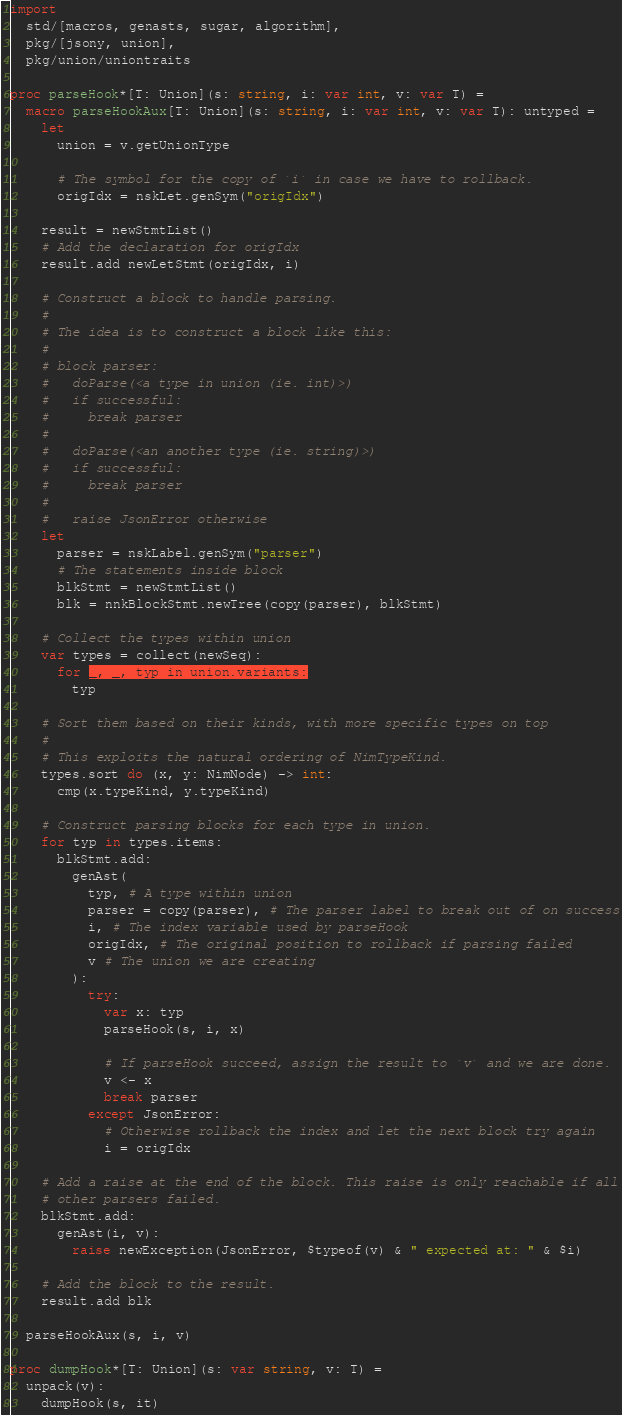Convert code to text. <code><loc_0><loc_0><loc_500><loc_500><_Nim_>import
  std/[macros, genasts, sugar, algorithm],
  pkg/[jsony, union],
  pkg/union/uniontraits

proc parseHook*[T: Union](s: string, i: var int, v: var T) =
  macro parseHookAux[T: Union](s: string, i: var int, v: var T): untyped =
    let
      union = v.getUnionType

      # The symbol for the copy of `i` in case we have to rollback.
      origIdx = nskLet.genSym("origIdx")

    result = newStmtList()
    # Add the declaration for origIdx
    result.add newLetStmt(origIdx, i)

    # Construct a block to handle parsing.
    #
    # The idea is to construct a block like this:
    #
    # block parser:
    #   doParse(<a type in union (ie. int)>)
    #   if successful:
    #     break parser
    #
    #   doParse(<an another type (ie. string)>)
    #   if successful:
    #     break parser
    #
    #   raise JsonError otherwise
    let
      parser = nskLabel.genSym("parser")
      # The statements inside block
      blkStmt = newStmtList()
      blk = nnkBlockStmt.newTree(copy(parser), blkStmt)

    # Collect the types within union
    var types = collect(newSeq):
      for _, _, typ in union.variants:
        typ

    # Sort them based on their kinds, with more specific types on top
    #
    # This exploits the natural ordering of NimTypeKind.
    types.sort do (x, y: NimNode) -> int:
      cmp(x.typeKind, y.typeKind)

    # Construct parsing blocks for each type in union.
    for typ in types.items:
      blkStmt.add:
        genAst(
          typ, # A type within union
          parser = copy(parser), # The parser label to break out of on success
          i, # The index variable used by parseHook
          origIdx, # The original position to rollback if parsing failed
          v # The union we are creating
        ):
          try:
            var x: typ
            parseHook(s, i, x)

            # If parseHook succeed, assign the result to `v` and we are done.
            v <- x
            break parser
          except JsonError:
            # Otherwise rollback the index and let the next block try again
            i = origIdx

    # Add a raise at the end of the block. This raise is only reachable if all
    # other parsers failed.
    blkStmt.add:
      genAst(i, v):
        raise newException(JsonError, $typeof(v) & " expected at: " & $i)

    # Add the block to the result.
    result.add blk

  parseHookAux(s, i, v)

proc dumpHook*[T: Union](s: var string, v: T) =
  unpack(v):
    dumpHook(s, it)
</code> 